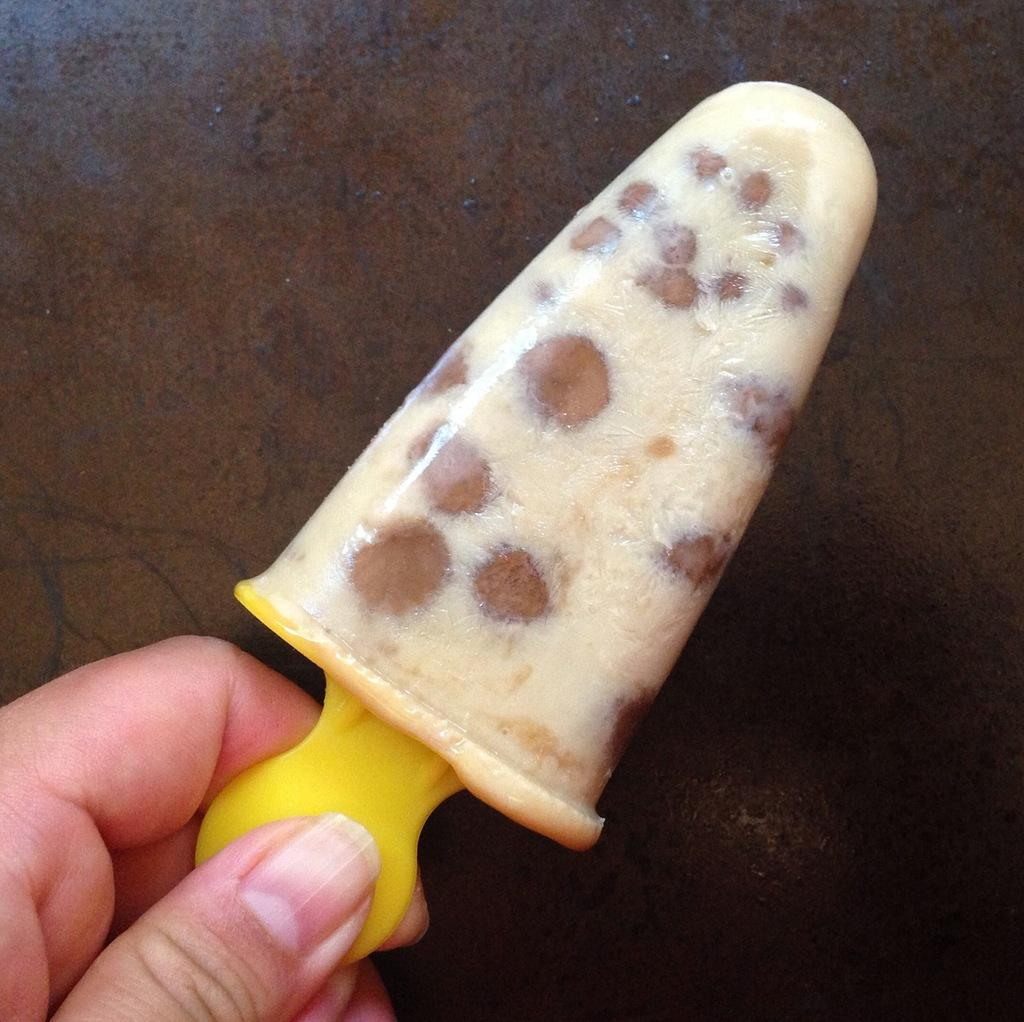What is the main subject of the image? The main subject of the image is a hand. What is the hand holding in the image? The hand is holding an ice-cream. What color is the tooth in the image? There is no tooth present in the image. 